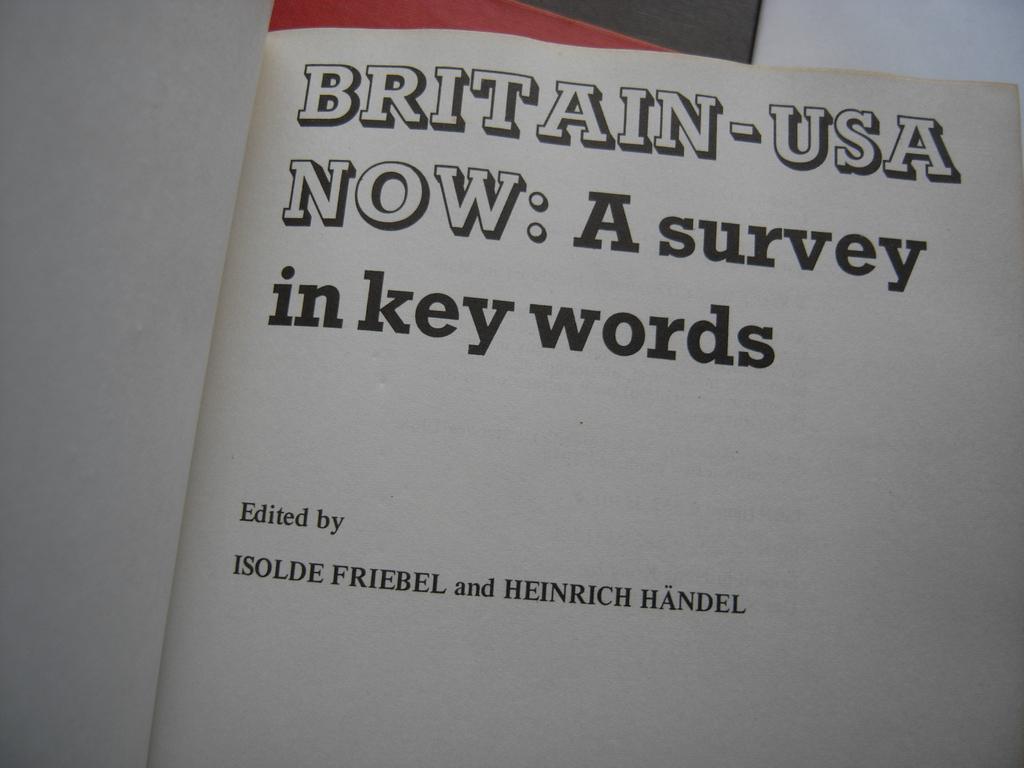Who was the survey edited by?
Provide a succinct answer. Isolde friebel and heinrich handel. What's the title of the survey?
Your response must be concise. Britain-usa now. 